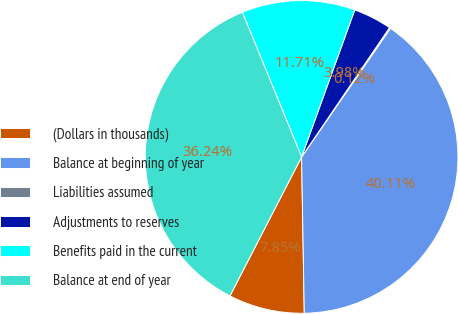Convert chart. <chart><loc_0><loc_0><loc_500><loc_500><pie_chart><fcel>(Dollars in thousands)<fcel>Balance at beginning of year<fcel>Liabilities assumed<fcel>Adjustments to reserves<fcel>Benefits paid in the current<fcel>Balance at end of year<nl><fcel>7.85%<fcel>40.11%<fcel>0.12%<fcel>3.98%<fcel>11.71%<fcel>36.24%<nl></chart> 